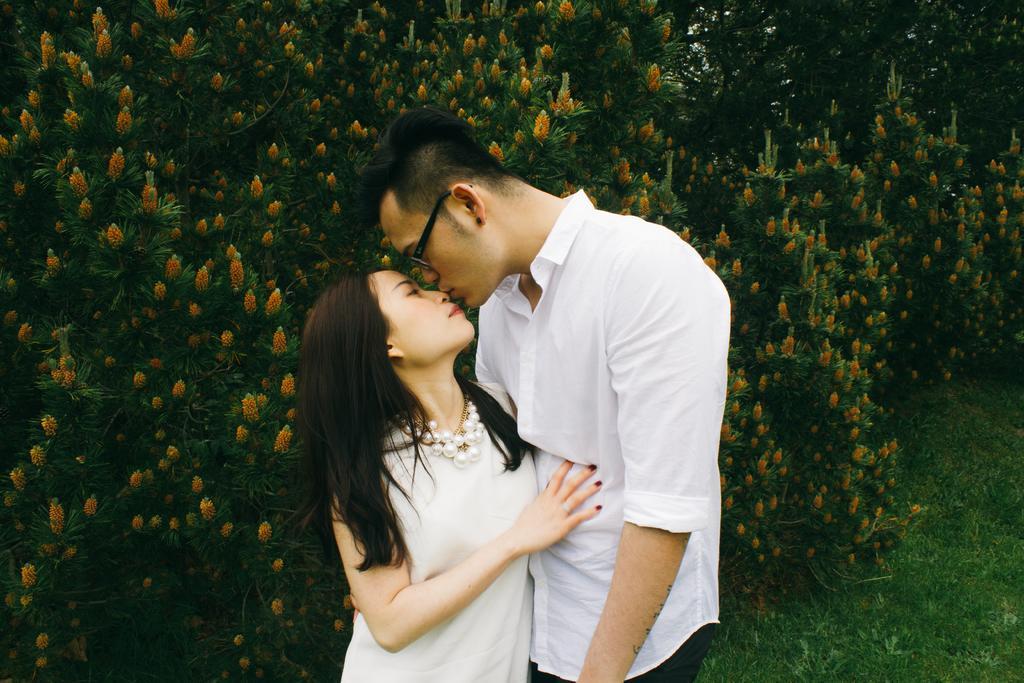Describe this image in one or two sentences. In this picture there is a couple standing. In the background there are trees and flowers. On the right there is grass. 